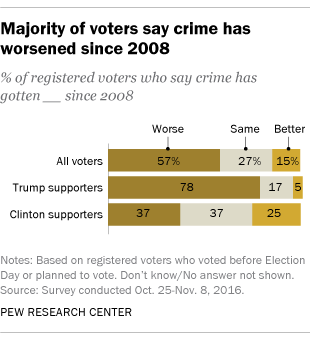Identify some key points in this picture. The average value of all orange bars is 15. 